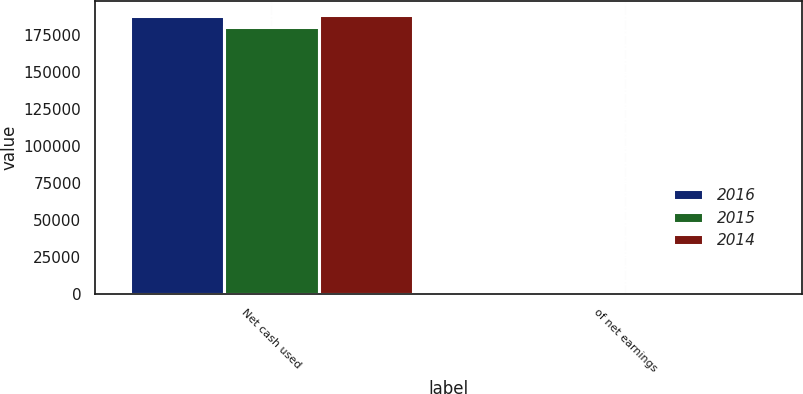Convert chart. <chart><loc_0><loc_0><loc_500><loc_500><stacked_bar_chart><ecel><fcel>Net cash used<fcel>of net earnings<nl><fcel>2016<fcel>188093<fcel>37.7<nl><fcel>2015<fcel>180627<fcel>35<nl><fcel>2014<fcel>188781<fcel>38.2<nl></chart> 